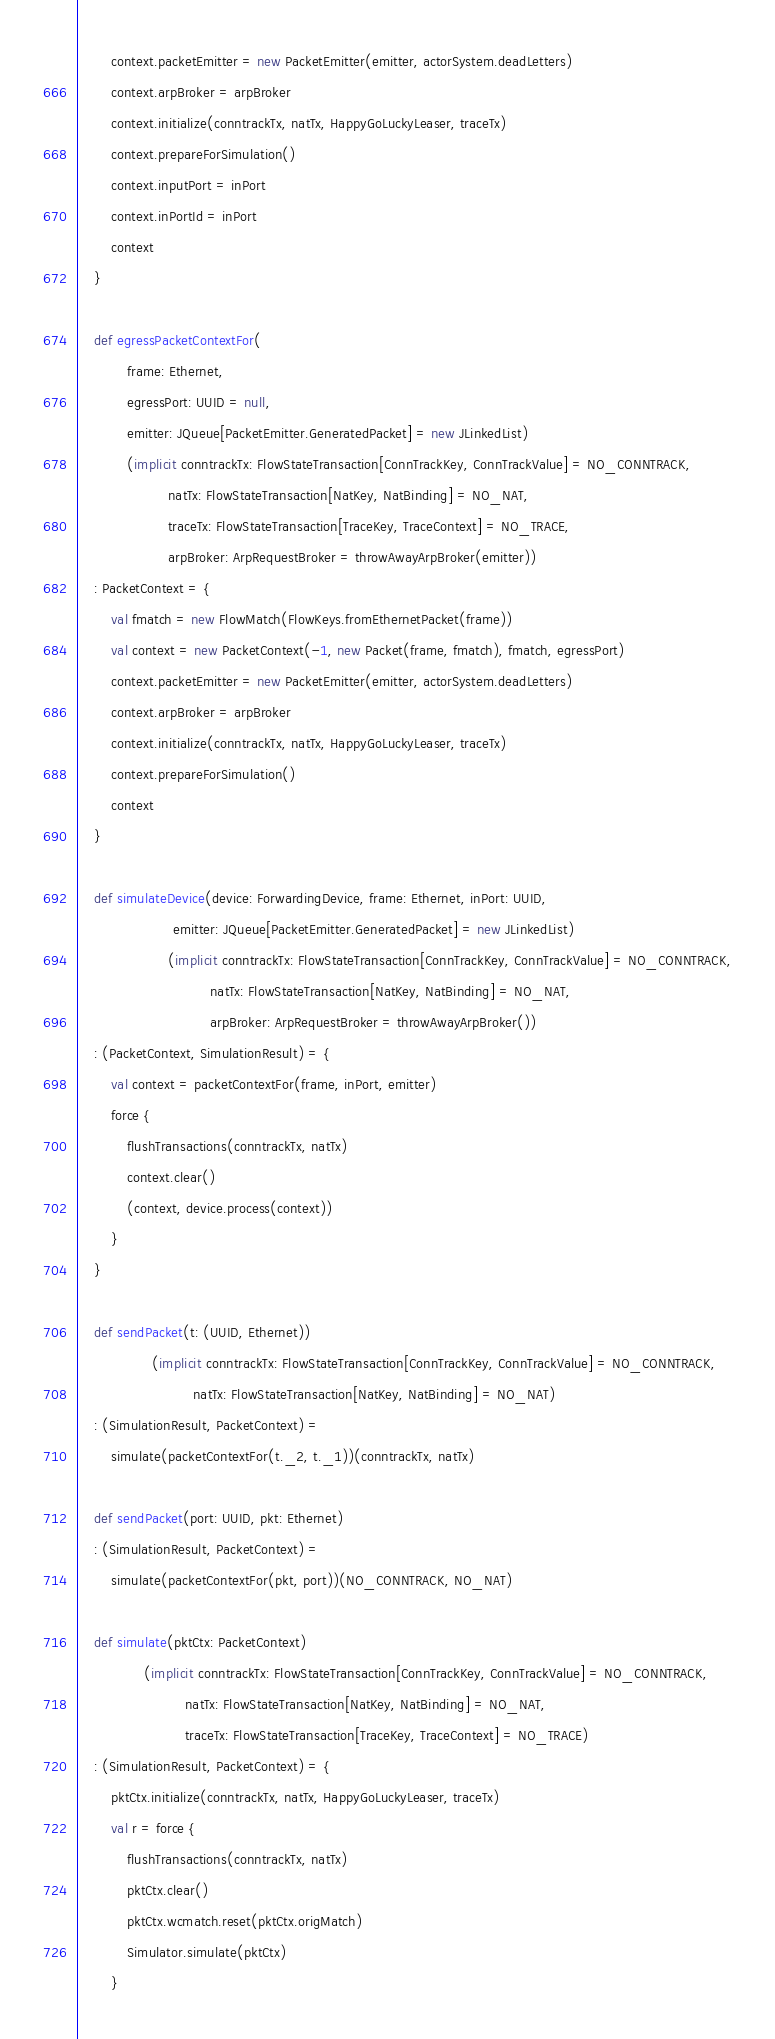Convert code to text. <code><loc_0><loc_0><loc_500><loc_500><_Scala_>        context.packetEmitter = new PacketEmitter(emitter, actorSystem.deadLetters)
        context.arpBroker = arpBroker
        context.initialize(conntrackTx, natTx, HappyGoLuckyLeaser, traceTx)
        context.prepareForSimulation()
        context.inputPort = inPort
        context.inPortId = inPort
        context
    }

    def egressPacketContextFor(
            frame: Ethernet,
            egressPort: UUID = null,
            emitter: JQueue[PacketEmitter.GeneratedPacket] = new JLinkedList)
            (implicit conntrackTx: FlowStateTransaction[ConnTrackKey, ConnTrackValue] = NO_CONNTRACK,
                      natTx: FlowStateTransaction[NatKey, NatBinding] = NO_NAT,
                      traceTx: FlowStateTransaction[TraceKey, TraceContext] = NO_TRACE,
                      arpBroker: ArpRequestBroker = throwAwayArpBroker(emitter))
    : PacketContext = {
        val fmatch = new FlowMatch(FlowKeys.fromEthernetPacket(frame))
        val context = new PacketContext(-1, new Packet(frame, fmatch), fmatch, egressPort)
        context.packetEmitter = new PacketEmitter(emitter, actorSystem.deadLetters)
        context.arpBroker = arpBroker
        context.initialize(conntrackTx, natTx, HappyGoLuckyLeaser, traceTx)
        context.prepareForSimulation()
        context
    }

    def simulateDevice(device: ForwardingDevice, frame: Ethernet, inPort: UUID,
                       emitter: JQueue[PacketEmitter.GeneratedPacket] = new JLinkedList)
                      (implicit conntrackTx: FlowStateTransaction[ConnTrackKey, ConnTrackValue] = NO_CONNTRACK,
                                natTx: FlowStateTransaction[NatKey, NatBinding] = NO_NAT,
                                arpBroker: ArpRequestBroker = throwAwayArpBroker())
    : (PacketContext, SimulationResult) = {
        val context = packetContextFor(frame, inPort, emitter)
        force {
            flushTransactions(conntrackTx, natTx)
            context.clear()
            (context, device.process(context))
        }
    }

    def sendPacket(t: (UUID, Ethernet))
                  (implicit conntrackTx: FlowStateTransaction[ConnTrackKey, ConnTrackValue] = NO_CONNTRACK,
                            natTx: FlowStateTransaction[NatKey, NatBinding] = NO_NAT)
    : (SimulationResult, PacketContext) =
        simulate(packetContextFor(t._2, t._1))(conntrackTx, natTx)

    def sendPacket(port: UUID, pkt: Ethernet)
    : (SimulationResult, PacketContext) =
        simulate(packetContextFor(pkt, port))(NO_CONNTRACK, NO_NAT)

    def simulate(pktCtx: PacketContext)
                (implicit conntrackTx: FlowStateTransaction[ConnTrackKey, ConnTrackValue] = NO_CONNTRACK,
                          natTx: FlowStateTransaction[NatKey, NatBinding] = NO_NAT,
                          traceTx: FlowStateTransaction[TraceKey, TraceContext] = NO_TRACE)
    : (SimulationResult, PacketContext) = {
        pktCtx.initialize(conntrackTx, natTx, HappyGoLuckyLeaser, traceTx)
        val r = force {
            flushTransactions(conntrackTx, natTx)
            pktCtx.clear()
            pktCtx.wcmatch.reset(pktCtx.origMatch)
            Simulator.simulate(pktCtx)
        }</code> 